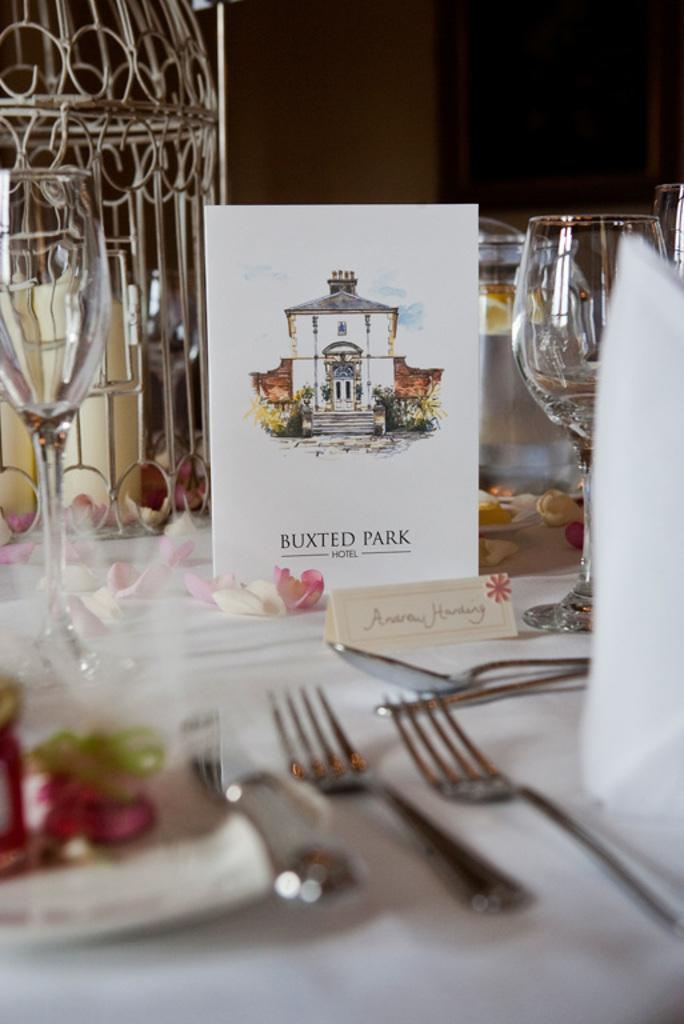What piece of furniture is visible in the image? There is a table in the image. What utensils can be seen on the table? There are forks and spoons on the table. What type of dishware is present on the table? There are glasses on the table. What is the primary mode of transportation in the image? There is a car in the image. What type of decoration is present on the table? Petals of a flower are present on the table. What can be used for cleaning or wiping in the image? Tissue papers are on the table. What is the lighting condition in the image? The background of the image is dark. How many kittens are playing with the tissue papers on the table? There are no kittens present in the image; only the table, utensils, glasses, car, petals, and tissue papers are visible. 